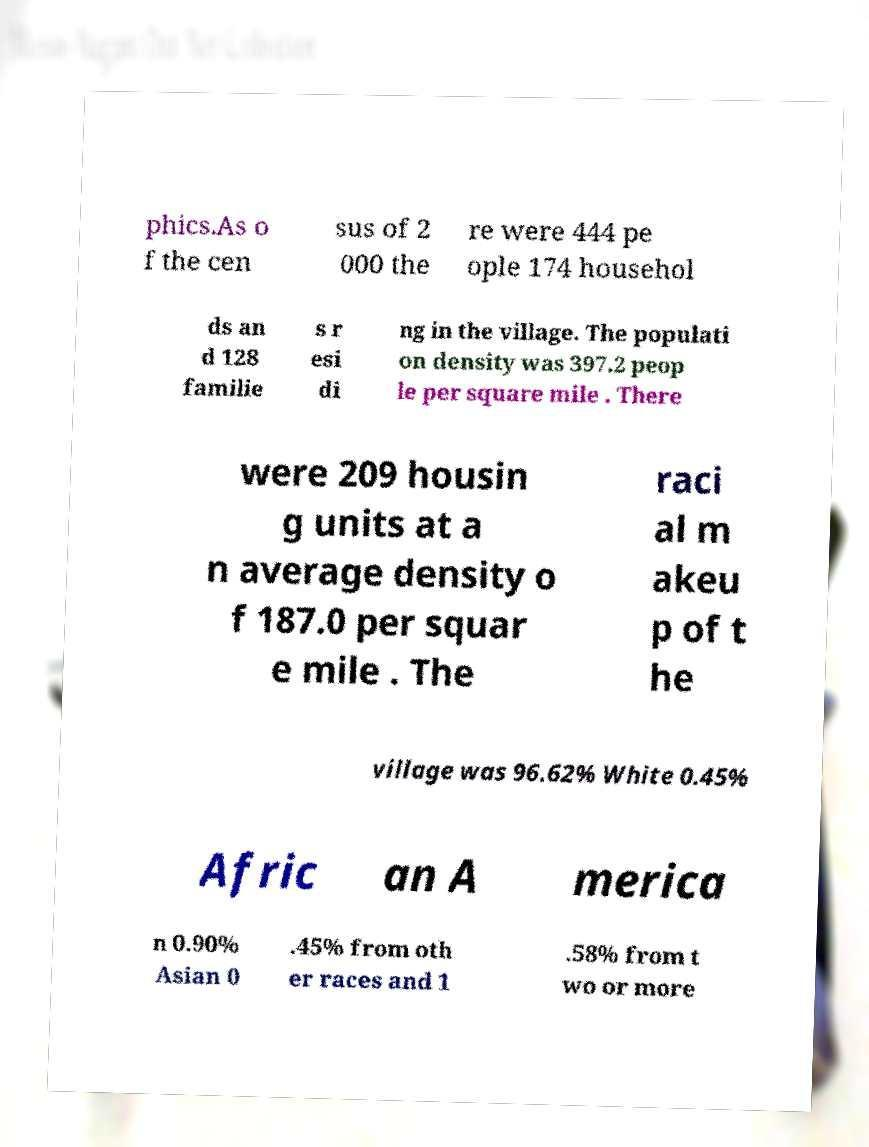For documentation purposes, I need the text within this image transcribed. Could you provide that? phics.As o f the cen sus of 2 000 the re were 444 pe ople 174 househol ds an d 128 familie s r esi di ng in the village. The populati on density was 397.2 peop le per square mile . There were 209 housin g units at a n average density o f 187.0 per squar e mile . The raci al m akeu p of t he village was 96.62% White 0.45% Afric an A merica n 0.90% Asian 0 .45% from oth er races and 1 .58% from t wo or more 